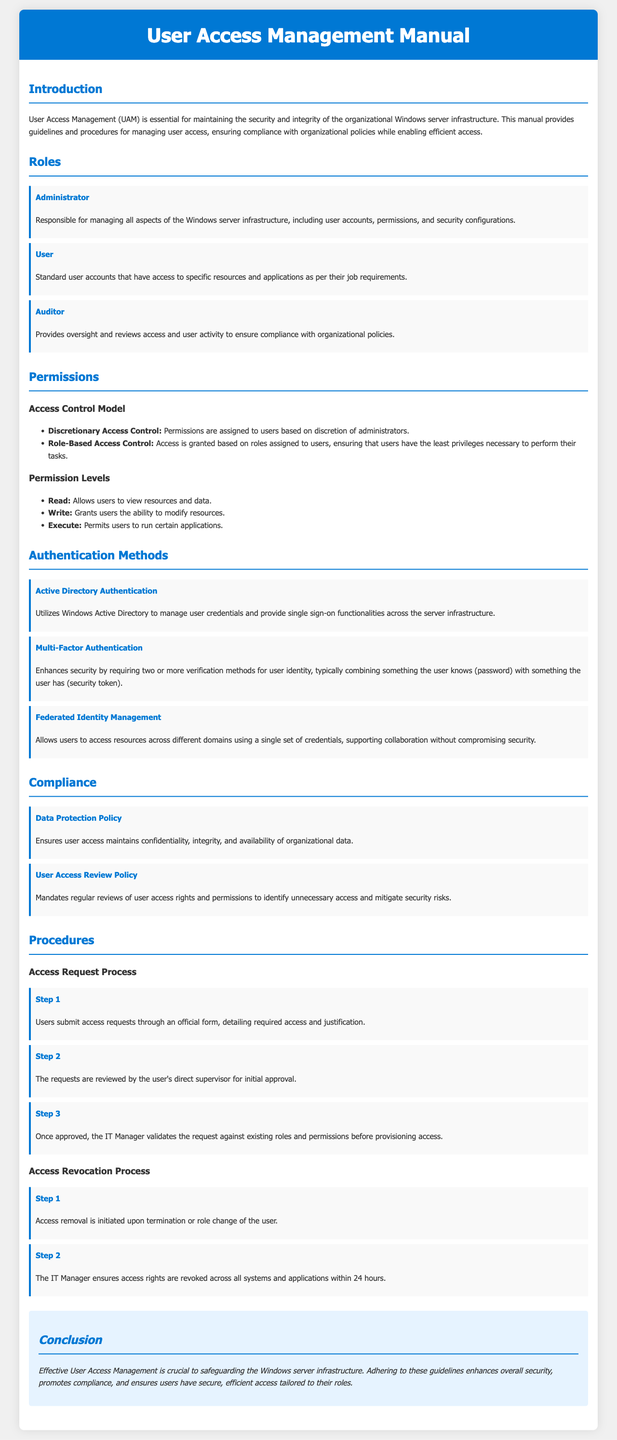What is the purpose of the User Access Management manual? The manual provides guidelines and procedures for managing user access, ensuring compliance with organizational policies while enabling efficient access.
Answer: Guidelines and procedures for managing user access What role is responsible for managing all aspects of the Windows server infrastructure? The document states that the Administrator is responsible for managing all aspects of the Windows server infrastructure.
Answer: Administrator What authentication method requires two or more verification methods? The document mentions Multi-Factor Authentication as requiring two or more verification methods for user identity.
Answer: Multi-Factor Authentication What does the Data Protection Policy ensure? The Data Protection Policy ensures user access maintains confidentiality, integrity, and availability of organizational data.
Answer: Confidentiality, integrity, and availability What is the first step in the Access Request Process? The first step involves users submitting access requests through an official form, detailing required access and justification.
Answer: Users submit access requests What is the timeframe for revoking access rights across all systems after a user's role change? The document specifies that access rights should be revoked by the IT Manager within 24 hours.
Answer: 24 hours How many roles are defined in the manual? The manual defines three roles: Administrator, User, and Auditor.
Answer: Three roles Which access control model grants access based on roles? The document specifies Role-Based Access Control as the model that grants access based on roles assigned to users.
Answer: Role-Based Access Control What is the final section of the manual titled? The final section of the manual is titled Conclusion.
Answer: Conclusion 